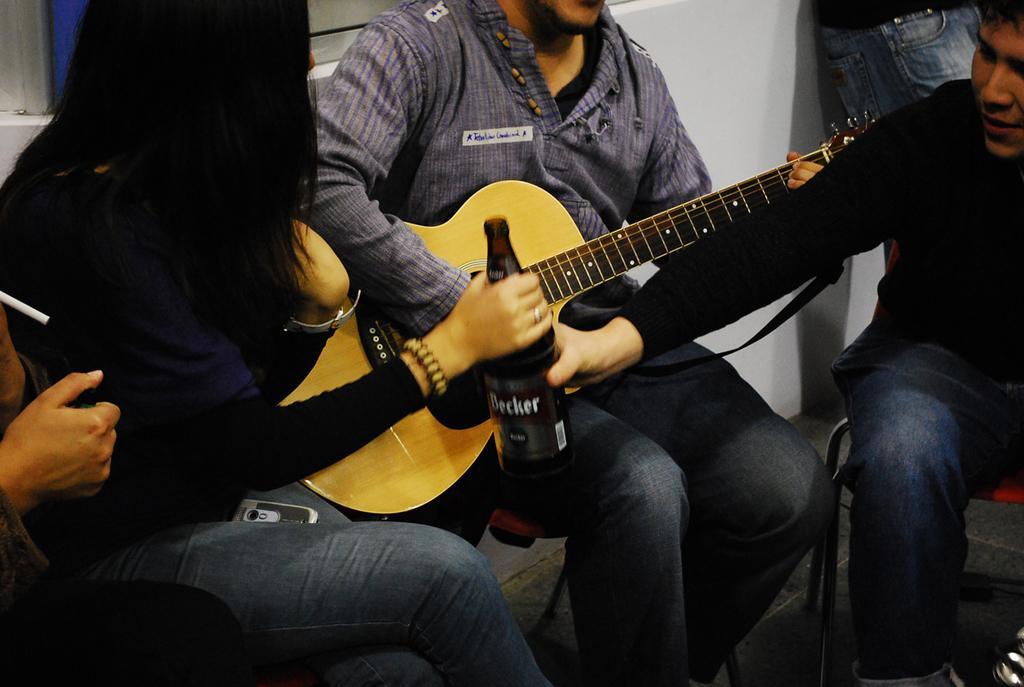Please provide a concise description of this image. In this picture we can find a man sitting with a guitar and just beside him there is a woman sitting and holding wine bottle. IN the background we can find a wall and person standing. 